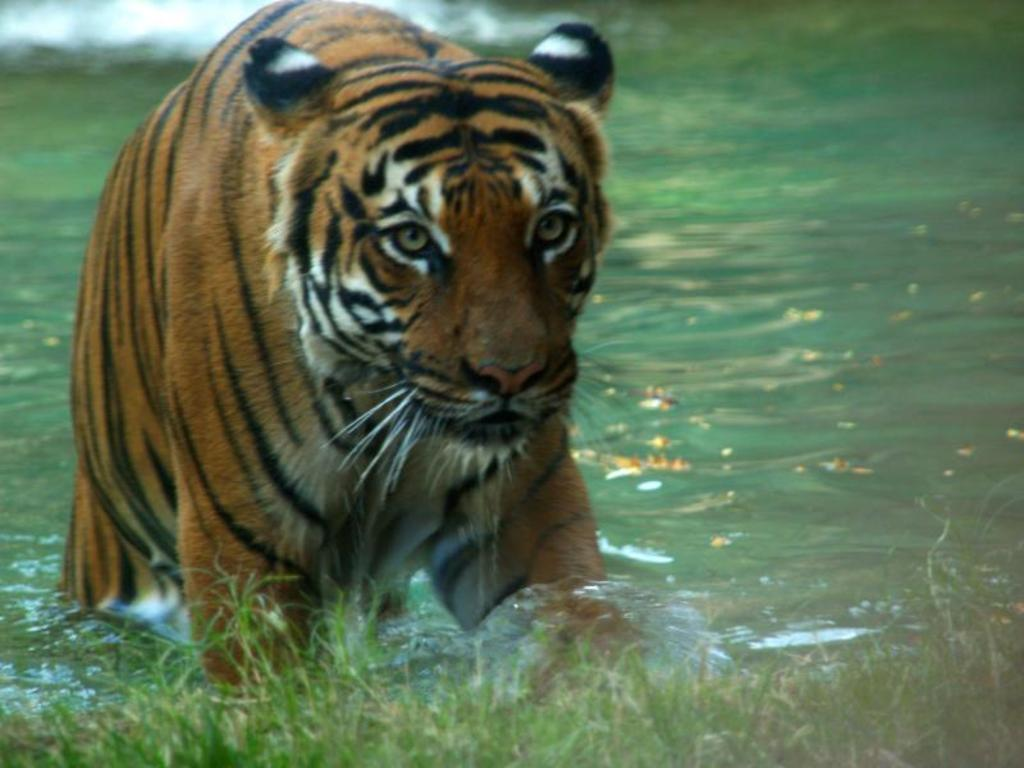What type of animal is in the image? There is a tiger in the image. What colors can be seen on the tiger? The tiger has brown, black, and white colors. What natural elements are visible in the image? There is water and grass visible in the image. What type of food is the tiger cooking in the image? There is no indication in the image that the tiger is cooking any food, as tigers are not known to cook. 